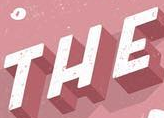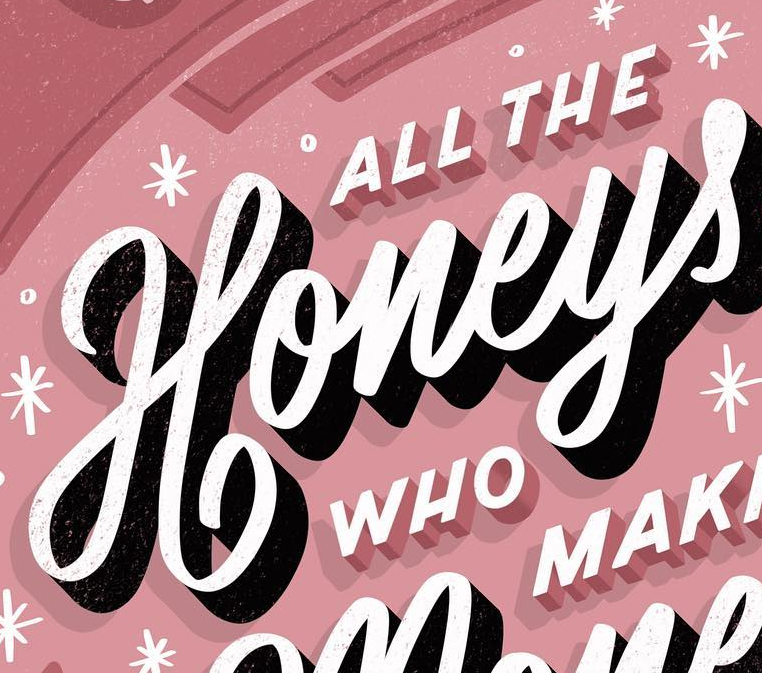Identify the words shown in these images in order, separated by a semicolon. THE; Honeys 